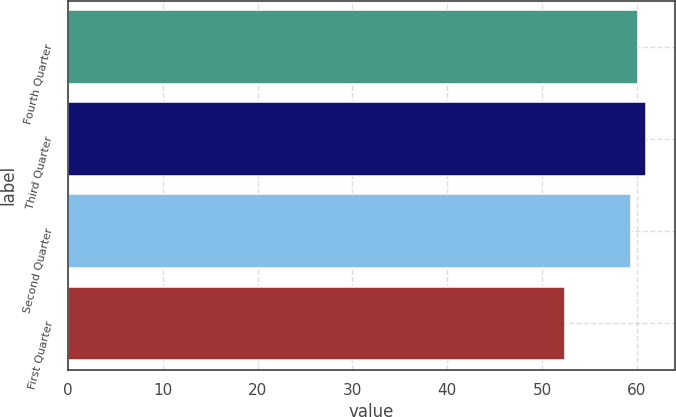Convert chart to OTSL. <chart><loc_0><loc_0><loc_500><loc_500><bar_chart><fcel>Fourth Quarter<fcel>Third Quarter<fcel>Second Quarter<fcel>First Quarter<nl><fcel>60.16<fcel>60.95<fcel>59.37<fcel>52.42<nl></chart> 